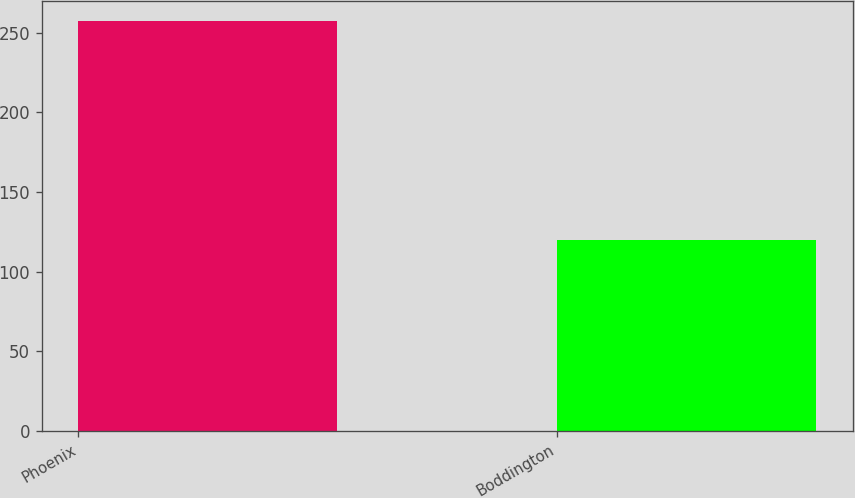Convert chart to OTSL. <chart><loc_0><loc_0><loc_500><loc_500><bar_chart><fcel>Phoenix<fcel>Boddington<nl><fcel>257<fcel>120<nl></chart> 